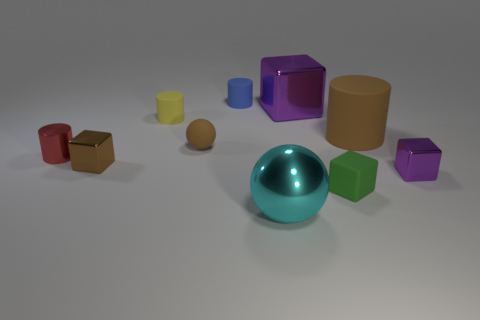Is there a metallic object of the same color as the big metal block?
Offer a terse response. Yes. There is a tiny matte thing that is the same color as the large cylinder; what is its shape?
Offer a very short reply. Sphere. What is the material of the tiny yellow object that is the same shape as the large brown rubber object?
Your answer should be compact. Rubber. How many other objects are there of the same size as the brown ball?
Your answer should be compact. 6. What is the shape of the purple shiny object that is behind the tiny cube left of the sphere left of the shiny sphere?
Your answer should be compact. Cube. There is a tiny thing that is both to the left of the small brown sphere and on the right side of the brown metal object; what is its shape?
Offer a very short reply. Cylinder. What number of objects are large red shiny blocks or tiny cylinders that are on the left side of the tiny blue cylinder?
Your answer should be compact. 2. Do the large purple block and the cyan sphere have the same material?
Ensure brevity in your answer.  Yes. What number of other things are there of the same shape as the brown metallic object?
Offer a terse response. 3. How big is the metal cube that is right of the small yellow object and in front of the red cylinder?
Your response must be concise. Small. 